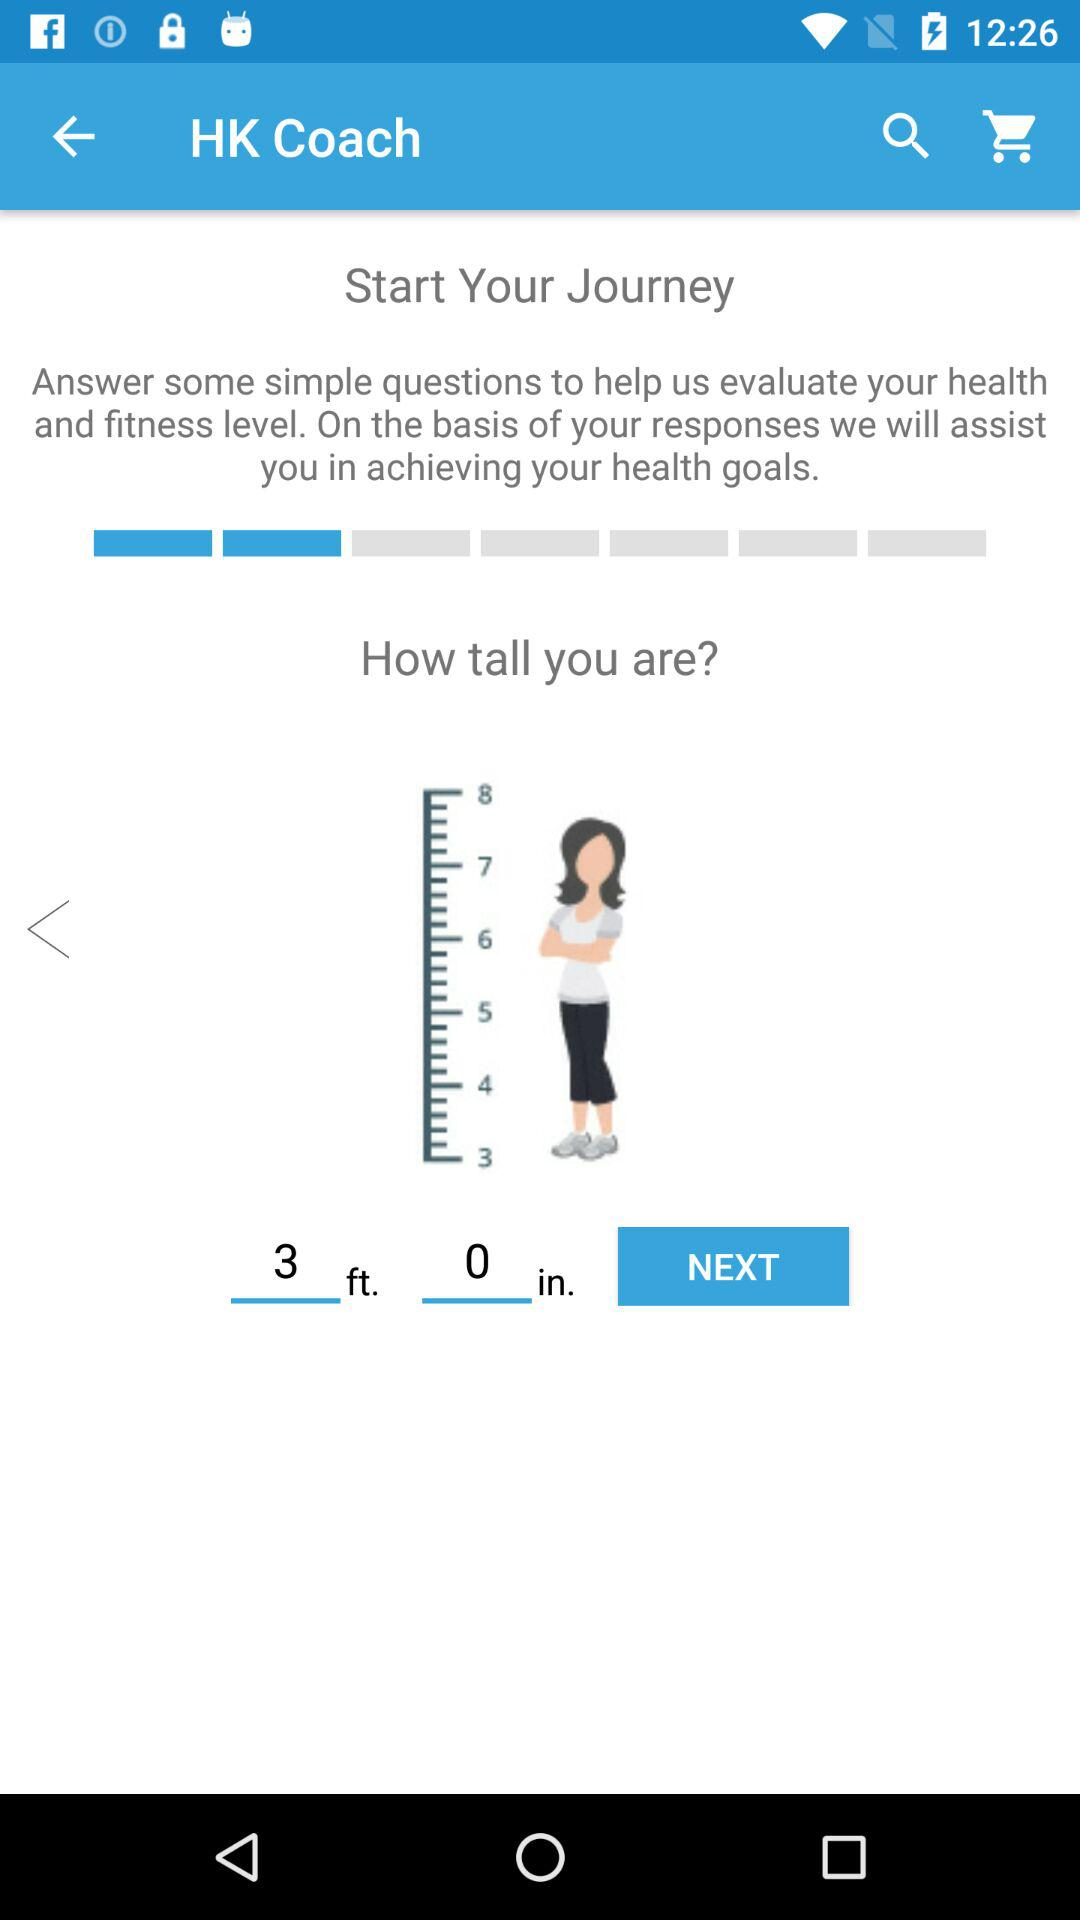What is the input height? The input height is 3 feet 0 inches. 